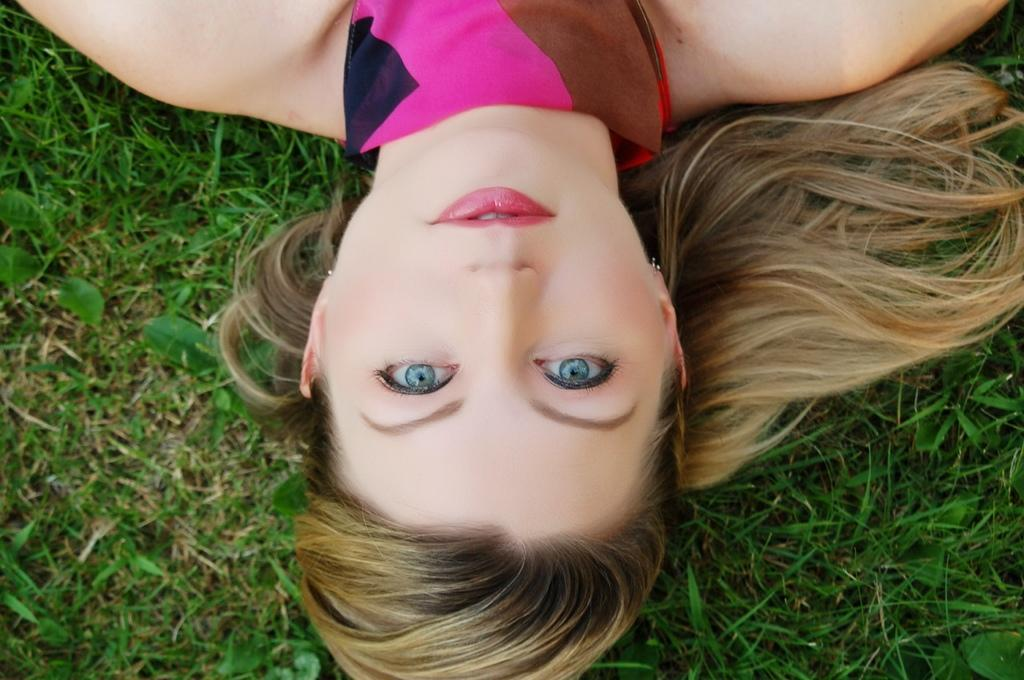Who is present in the image? There is a woman in the image. What is the woman's location in the image? The woman is on the grass. Is there a man in the image helping the woman make adjustments to the paste? There is no man or paste present in the image. 